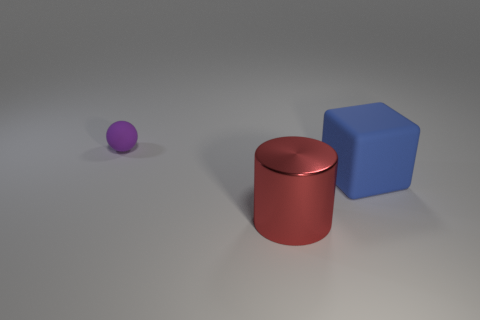Add 2 big purple matte cubes. How many objects exist? 5 Add 2 big cylinders. How many big cylinders are left? 3 Add 2 red shiny things. How many red shiny things exist? 3 Subtract 0 red spheres. How many objects are left? 3 Subtract all cubes. How many objects are left? 2 Subtract all big blocks. Subtract all large shiny cylinders. How many objects are left? 1 